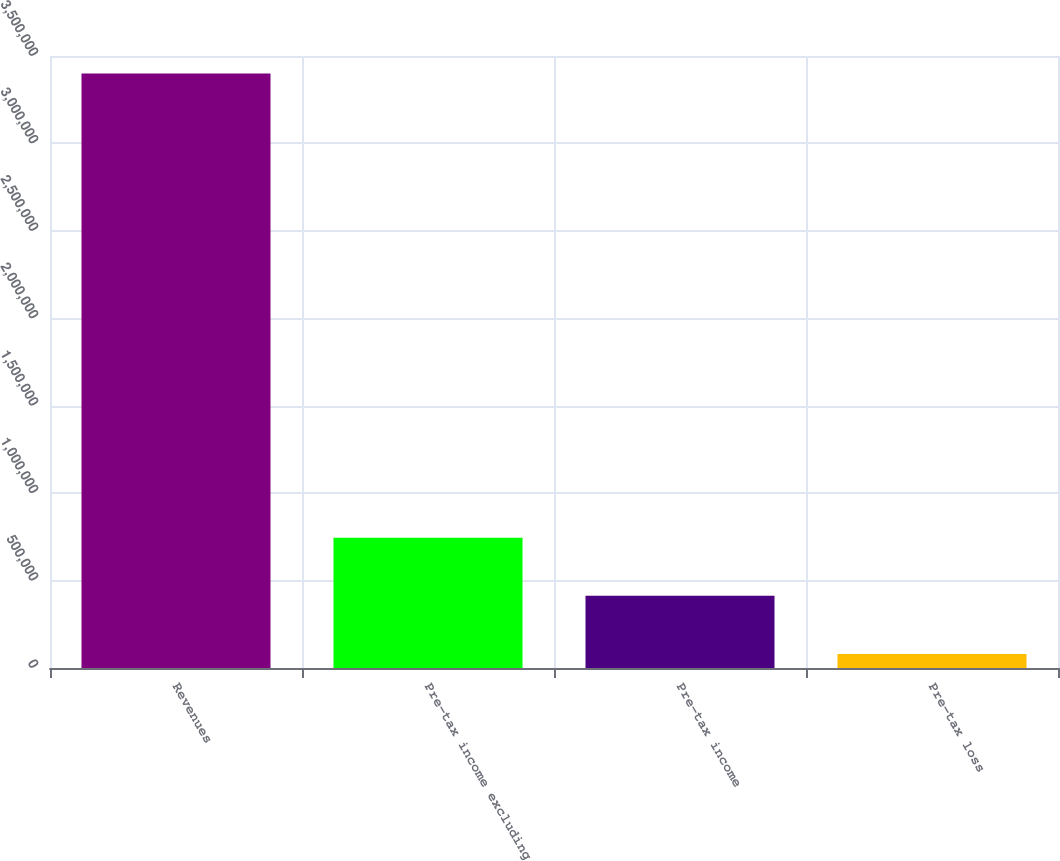<chart> <loc_0><loc_0><loc_500><loc_500><bar_chart><fcel>Revenues<fcel>Pre-tax income excluding<fcel>Pre-tax income<fcel>Pre-tax loss<nl><fcel>3.39989e+06<fcel>744571<fcel>412656<fcel>80742<nl></chart> 